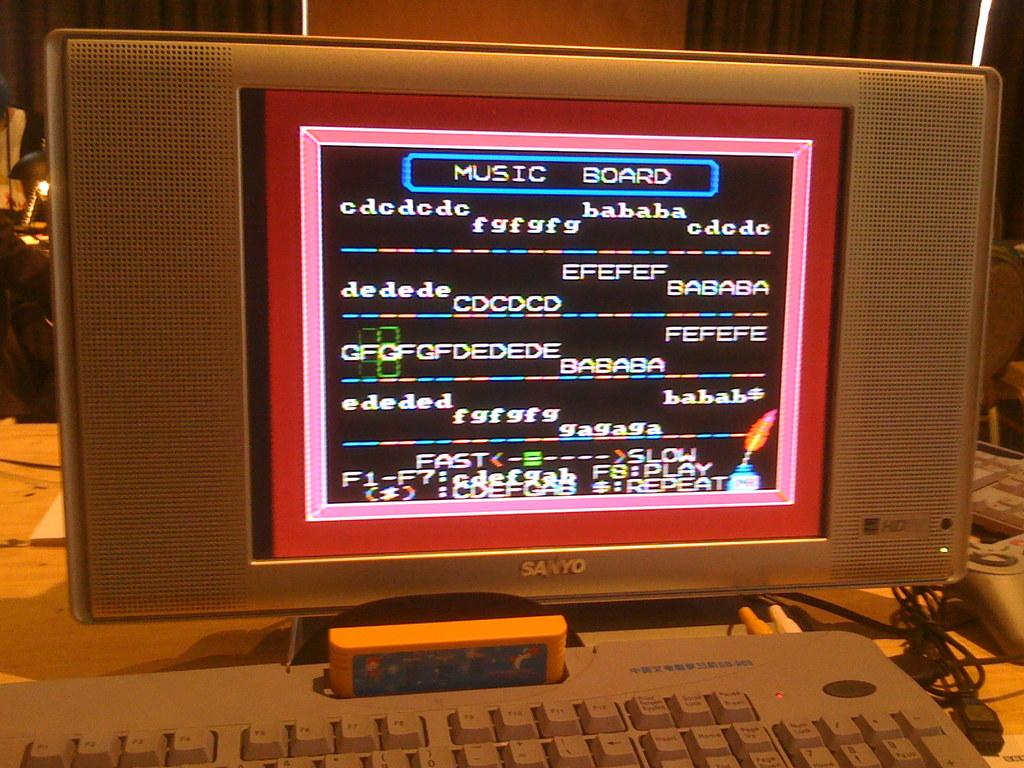<image>
Provide a brief description of the given image. a computer with a music board on the screen 